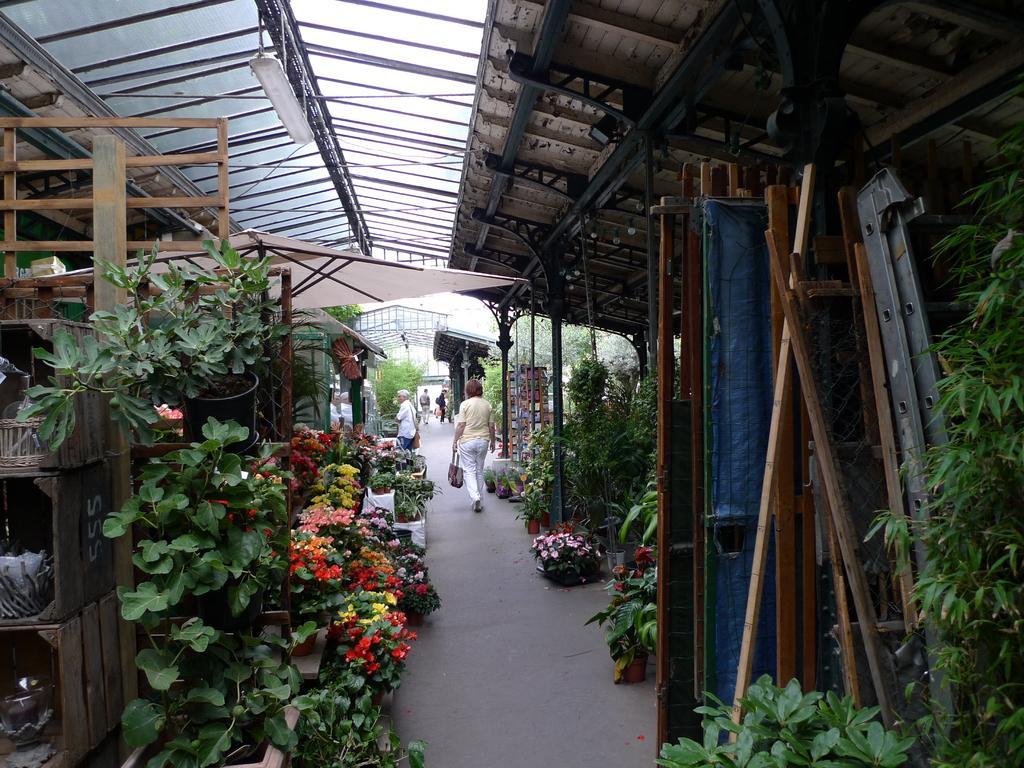Describe this image in one or two sentences. On the left side, there are pot plants arranged. Some of them are having flowers. On the right side, there are plants. In the middle, there is a road on which, there are persons. Above this road, there is roof. In the background, there are persons and there are trees. 